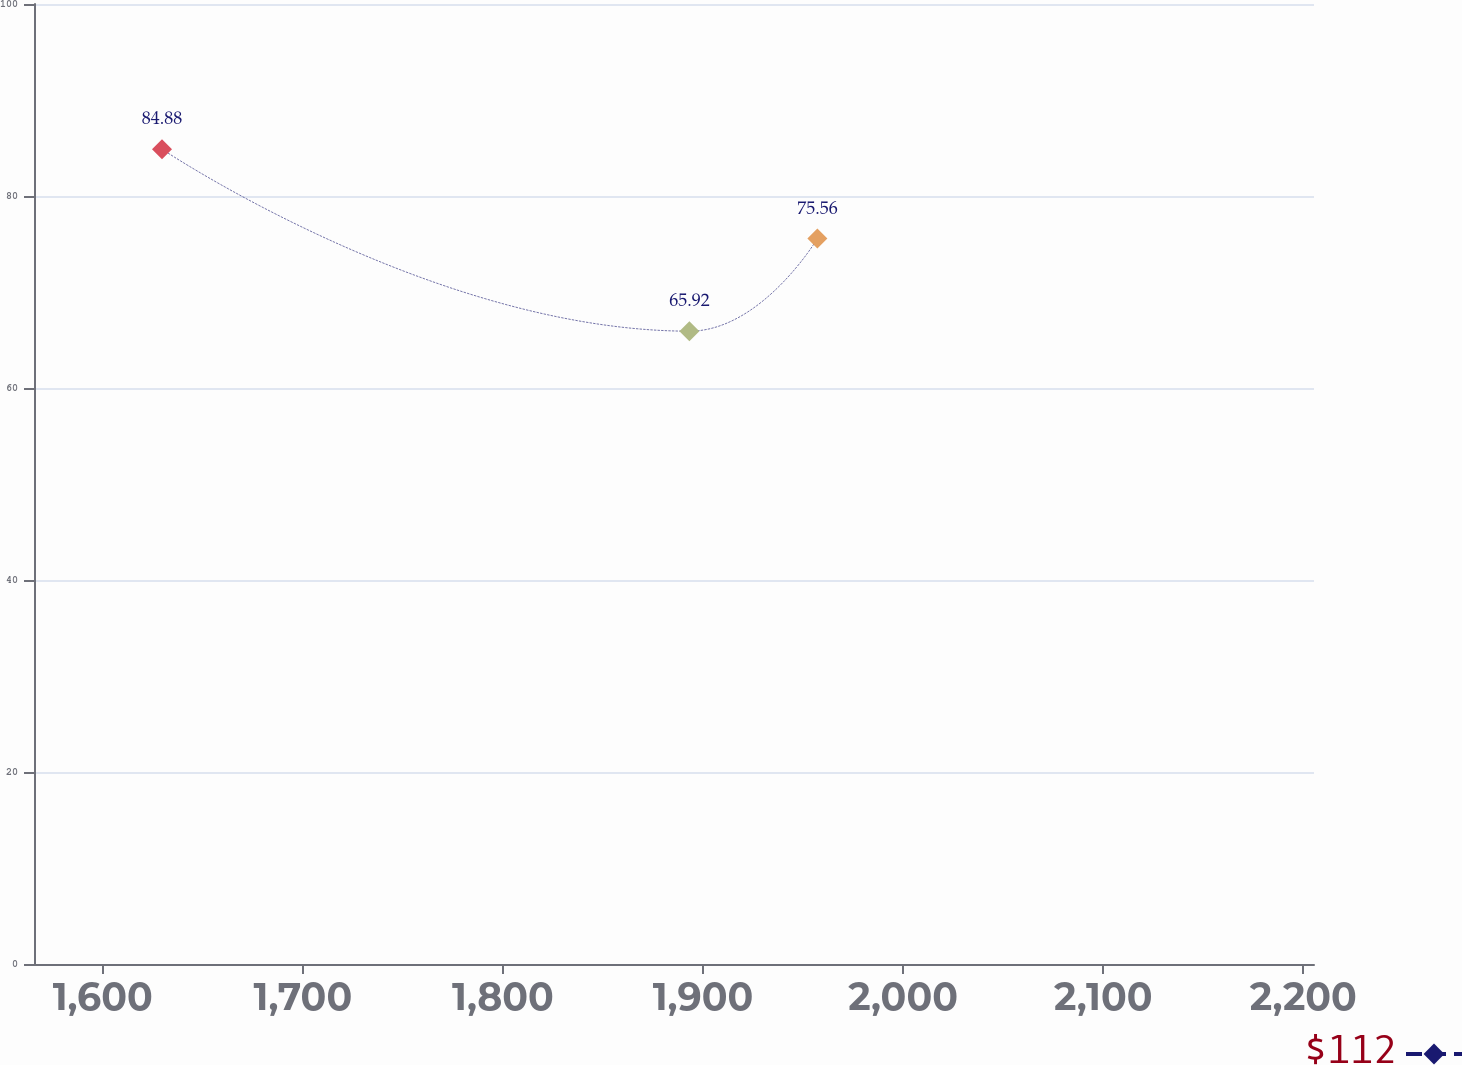Convert chart. <chart><loc_0><loc_0><loc_500><loc_500><line_chart><ecel><fcel>$112<nl><fcel>1629.6<fcel>84.88<nl><fcel>1893.17<fcel>65.92<nl><fcel>1957.14<fcel>75.56<nl><fcel>2269.3<fcel>57.29<nl></chart> 